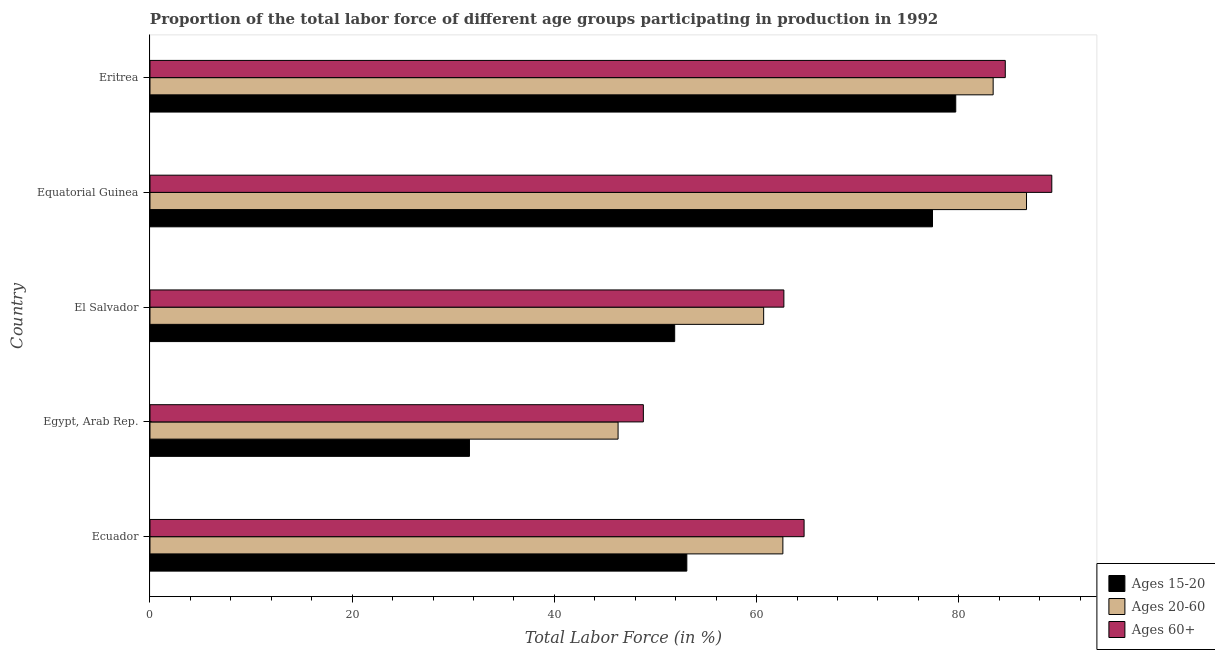How many different coloured bars are there?
Make the answer very short. 3. Are the number of bars per tick equal to the number of legend labels?
Provide a succinct answer. Yes. Are the number of bars on each tick of the Y-axis equal?
Ensure brevity in your answer.  Yes. How many bars are there on the 1st tick from the top?
Your answer should be very brief. 3. How many bars are there on the 1st tick from the bottom?
Provide a short and direct response. 3. What is the label of the 3rd group of bars from the top?
Provide a succinct answer. El Salvador. What is the percentage of labor force within the age group 15-20 in El Salvador?
Offer a very short reply. 51.9. Across all countries, what is the maximum percentage of labor force within the age group 15-20?
Ensure brevity in your answer.  79.7. Across all countries, what is the minimum percentage of labor force within the age group 20-60?
Keep it short and to the point. 46.3. In which country was the percentage of labor force within the age group 15-20 maximum?
Keep it short and to the point. Eritrea. In which country was the percentage of labor force within the age group 15-20 minimum?
Provide a short and direct response. Egypt, Arab Rep. What is the total percentage of labor force within the age group 20-60 in the graph?
Provide a succinct answer. 339.7. What is the difference between the percentage of labor force within the age group 15-20 in Egypt, Arab Rep. and that in Equatorial Guinea?
Provide a succinct answer. -45.8. What is the difference between the percentage of labor force within the age group 15-20 in Eritrea and the percentage of labor force above age 60 in Equatorial Guinea?
Make the answer very short. -9.5. What is the average percentage of labor force within the age group 15-20 per country?
Offer a very short reply. 58.74. What is the difference between the percentage of labor force above age 60 and percentage of labor force within the age group 15-20 in Equatorial Guinea?
Make the answer very short. 11.8. What is the ratio of the percentage of labor force above age 60 in Egypt, Arab Rep. to that in El Salvador?
Ensure brevity in your answer.  0.78. Is the percentage of labor force within the age group 15-20 in Egypt, Arab Rep. less than that in Eritrea?
Ensure brevity in your answer.  Yes. Is the difference between the percentage of labor force within the age group 20-60 in Egypt, Arab Rep. and El Salvador greater than the difference between the percentage of labor force above age 60 in Egypt, Arab Rep. and El Salvador?
Provide a short and direct response. No. What is the difference between the highest and the lowest percentage of labor force within the age group 15-20?
Your response must be concise. 48.1. Is the sum of the percentage of labor force within the age group 20-60 in Ecuador and Equatorial Guinea greater than the maximum percentage of labor force within the age group 15-20 across all countries?
Your response must be concise. Yes. What does the 2nd bar from the top in Eritrea represents?
Give a very brief answer. Ages 20-60. What does the 3rd bar from the bottom in Equatorial Guinea represents?
Give a very brief answer. Ages 60+. What is the difference between two consecutive major ticks on the X-axis?
Your answer should be very brief. 20. Does the graph contain any zero values?
Provide a short and direct response. No. What is the title of the graph?
Your response must be concise. Proportion of the total labor force of different age groups participating in production in 1992. Does "Industry" appear as one of the legend labels in the graph?
Your response must be concise. No. What is the Total Labor Force (in %) in Ages 15-20 in Ecuador?
Your answer should be compact. 53.1. What is the Total Labor Force (in %) of Ages 20-60 in Ecuador?
Offer a terse response. 62.6. What is the Total Labor Force (in %) of Ages 60+ in Ecuador?
Your answer should be compact. 64.7. What is the Total Labor Force (in %) in Ages 15-20 in Egypt, Arab Rep.?
Keep it short and to the point. 31.6. What is the Total Labor Force (in %) in Ages 20-60 in Egypt, Arab Rep.?
Offer a very short reply. 46.3. What is the Total Labor Force (in %) of Ages 60+ in Egypt, Arab Rep.?
Your answer should be very brief. 48.8. What is the Total Labor Force (in %) in Ages 15-20 in El Salvador?
Make the answer very short. 51.9. What is the Total Labor Force (in %) in Ages 20-60 in El Salvador?
Offer a terse response. 60.7. What is the Total Labor Force (in %) of Ages 60+ in El Salvador?
Give a very brief answer. 62.7. What is the Total Labor Force (in %) of Ages 15-20 in Equatorial Guinea?
Ensure brevity in your answer.  77.4. What is the Total Labor Force (in %) of Ages 20-60 in Equatorial Guinea?
Your answer should be compact. 86.7. What is the Total Labor Force (in %) of Ages 60+ in Equatorial Guinea?
Give a very brief answer. 89.2. What is the Total Labor Force (in %) in Ages 15-20 in Eritrea?
Your answer should be very brief. 79.7. What is the Total Labor Force (in %) of Ages 20-60 in Eritrea?
Your answer should be compact. 83.4. What is the Total Labor Force (in %) in Ages 60+ in Eritrea?
Keep it short and to the point. 84.6. Across all countries, what is the maximum Total Labor Force (in %) in Ages 15-20?
Offer a terse response. 79.7. Across all countries, what is the maximum Total Labor Force (in %) of Ages 20-60?
Provide a short and direct response. 86.7. Across all countries, what is the maximum Total Labor Force (in %) in Ages 60+?
Offer a very short reply. 89.2. Across all countries, what is the minimum Total Labor Force (in %) of Ages 15-20?
Offer a terse response. 31.6. Across all countries, what is the minimum Total Labor Force (in %) of Ages 20-60?
Offer a terse response. 46.3. Across all countries, what is the minimum Total Labor Force (in %) in Ages 60+?
Offer a terse response. 48.8. What is the total Total Labor Force (in %) in Ages 15-20 in the graph?
Give a very brief answer. 293.7. What is the total Total Labor Force (in %) of Ages 20-60 in the graph?
Your response must be concise. 339.7. What is the total Total Labor Force (in %) in Ages 60+ in the graph?
Make the answer very short. 350. What is the difference between the Total Labor Force (in %) of Ages 15-20 in Ecuador and that in Egypt, Arab Rep.?
Provide a short and direct response. 21.5. What is the difference between the Total Labor Force (in %) in Ages 20-60 in Ecuador and that in Egypt, Arab Rep.?
Your response must be concise. 16.3. What is the difference between the Total Labor Force (in %) in Ages 60+ in Ecuador and that in Egypt, Arab Rep.?
Keep it short and to the point. 15.9. What is the difference between the Total Labor Force (in %) of Ages 15-20 in Ecuador and that in Equatorial Guinea?
Provide a succinct answer. -24.3. What is the difference between the Total Labor Force (in %) in Ages 20-60 in Ecuador and that in Equatorial Guinea?
Provide a succinct answer. -24.1. What is the difference between the Total Labor Force (in %) of Ages 60+ in Ecuador and that in Equatorial Guinea?
Make the answer very short. -24.5. What is the difference between the Total Labor Force (in %) of Ages 15-20 in Ecuador and that in Eritrea?
Your answer should be compact. -26.6. What is the difference between the Total Labor Force (in %) in Ages 20-60 in Ecuador and that in Eritrea?
Make the answer very short. -20.8. What is the difference between the Total Labor Force (in %) in Ages 60+ in Ecuador and that in Eritrea?
Your response must be concise. -19.9. What is the difference between the Total Labor Force (in %) of Ages 15-20 in Egypt, Arab Rep. and that in El Salvador?
Your answer should be compact. -20.3. What is the difference between the Total Labor Force (in %) in Ages 20-60 in Egypt, Arab Rep. and that in El Salvador?
Your answer should be very brief. -14.4. What is the difference between the Total Labor Force (in %) in Ages 15-20 in Egypt, Arab Rep. and that in Equatorial Guinea?
Make the answer very short. -45.8. What is the difference between the Total Labor Force (in %) in Ages 20-60 in Egypt, Arab Rep. and that in Equatorial Guinea?
Your answer should be compact. -40.4. What is the difference between the Total Labor Force (in %) of Ages 60+ in Egypt, Arab Rep. and that in Equatorial Guinea?
Offer a very short reply. -40.4. What is the difference between the Total Labor Force (in %) of Ages 15-20 in Egypt, Arab Rep. and that in Eritrea?
Your response must be concise. -48.1. What is the difference between the Total Labor Force (in %) in Ages 20-60 in Egypt, Arab Rep. and that in Eritrea?
Your answer should be very brief. -37.1. What is the difference between the Total Labor Force (in %) in Ages 60+ in Egypt, Arab Rep. and that in Eritrea?
Your response must be concise. -35.8. What is the difference between the Total Labor Force (in %) in Ages 15-20 in El Salvador and that in Equatorial Guinea?
Give a very brief answer. -25.5. What is the difference between the Total Labor Force (in %) of Ages 20-60 in El Salvador and that in Equatorial Guinea?
Offer a terse response. -26. What is the difference between the Total Labor Force (in %) of Ages 60+ in El Salvador and that in Equatorial Guinea?
Offer a very short reply. -26.5. What is the difference between the Total Labor Force (in %) of Ages 15-20 in El Salvador and that in Eritrea?
Give a very brief answer. -27.8. What is the difference between the Total Labor Force (in %) of Ages 20-60 in El Salvador and that in Eritrea?
Keep it short and to the point. -22.7. What is the difference between the Total Labor Force (in %) in Ages 60+ in El Salvador and that in Eritrea?
Make the answer very short. -21.9. What is the difference between the Total Labor Force (in %) of Ages 60+ in Equatorial Guinea and that in Eritrea?
Keep it short and to the point. 4.6. What is the difference between the Total Labor Force (in %) of Ages 15-20 in Ecuador and the Total Labor Force (in %) of Ages 20-60 in Egypt, Arab Rep.?
Ensure brevity in your answer.  6.8. What is the difference between the Total Labor Force (in %) of Ages 15-20 in Ecuador and the Total Labor Force (in %) of Ages 60+ in Egypt, Arab Rep.?
Your answer should be very brief. 4.3. What is the difference between the Total Labor Force (in %) of Ages 15-20 in Ecuador and the Total Labor Force (in %) of Ages 60+ in El Salvador?
Your answer should be very brief. -9.6. What is the difference between the Total Labor Force (in %) of Ages 20-60 in Ecuador and the Total Labor Force (in %) of Ages 60+ in El Salvador?
Make the answer very short. -0.1. What is the difference between the Total Labor Force (in %) of Ages 15-20 in Ecuador and the Total Labor Force (in %) of Ages 20-60 in Equatorial Guinea?
Offer a terse response. -33.6. What is the difference between the Total Labor Force (in %) in Ages 15-20 in Ecuador and the Total Labor Force (in %) in Ages 60+ in Equatorial Guinea?
Offer a very short reply. -36.1. What is the difference between the Total Labor Force (in %) of Ages 20-60 in Ecuador and the Total Labor Force (in %) of Ages 60+ in Equatorial Guinea?
Provide a succinct answer. -26.6. What is the difference between the Total Labor Force (in %) in Ages 15-20 in Ecuador and the Total Labor Force (in %) in Ages 20-60 in Eritrea?
Provide a succinct answer. -30.3. What is the difference between the Total Labor Force (in %) of Ages 15-20 in Ecuador and the Total Labor Force (in %) of Ages 60+ in Eritrea?
Your response must be concise. -31.5. What is the difference between the Total Labor Force (in %) of Ages 20-60 in Ecuador and the Total Labor Force (in %) of Ages 60+ in Eritrea?
Give a very brief answer. -22. What is the difference between the Total Labor Force (in %) of Ages 15-20 in Egypt, Arab Rep. and the Total Labor Force (in %) of Ages 20-60 in El Salvador?
Your answer should be very brief. -29.1. What is the difference between the Total Labor Force (in %) of Ages 15-20 in Egypt, Arab Rep. and the Total Labor Force (in %) of Ages 60+ in El Salvador?
Provide a short and direct response. -31.1. What is the difference between the Total Labor Force (in %) in Ages 20-60 in Egypt, Arab Rep. and the Total Labor Force (in %) in Ages 60+ in El Salvador?
Give a very brief answer. -16.4. What is the difference between the Total Labor Force (in %) of Ages 15-20 in Egypt, Arab Rep. and the Total Labor Force (in %) of Ages 20-60 in Equatorial Guinea?
Give a very brief answer. -55.1. What is the difference between the Total Labor Force (in %) of Ages 15-20 in Egypt, Arab Rep. and the Total Labor Force (in %) of Ages 60+ in Equatorial Guinea?
Your response must be concise. -57.6. What is the difference between the Total Labor Force (in %) in Ages 20-60 in Egypt, Arab Rep. and the Total Labor Force (in %) in Ages 60+ in Equatorial Guinea?
Provide a succinct answer. -42.9. What is the difference between the Total Labor Force (in %) of Ages 15-20 in Egypt, Arab Rep. and the Total Labor Force (in %) of Ages 20-60 in Eritrea?
Provide a succinct answer. -51.8. What is the difference between the Total Labor Force (in %) of Ages 15-20 in Egypt, Arab Rep. and the Total Labor Force (in %) of Ages 60+ in Eritrea?
Offer a terse response. -53. What is the difference between the Total Labor Force (in %) of Ages 20-60 in Egypt, Arab Rep. and the Total Labor Force (in %) of Ages 60+ in Eritrea?
Ensure brevity in your answer.  -38.3. What is the difference between the Total Labor Force (in %) of Ages 15-20 in El Salvador and the Total Labor Force (in %) of Ages 20-60 in Equatorial Guinea?
Provide a short and direct response. -34.8. What is the difference between the Total Labor Force (in %) in Ages 15-20 in El Salvador and the Total Labor Force (in %) in Ages 60+ in Equatorial Guinea?
Your response must be concise. -37.3. What is the difference between the Total Labor Force (in %) of Ages 20-60 in El Salvador and the Total Labor Force (in %) of Ages 60+ in Equatorial Guinea?
Provide a short and direct response. -28.5. What is the difference between the Total Labor Force (in %) of Ages 15-20 in El Salvador and the Total Labor Force (in %) of Ages 20-60 in Eritrea?
Provide a succinct answer. -31.5. What is the difference between the Total Labor Force (in %) of Ages 15-20 in El Salvador and the Total Labor Force (in %) of Ages 60+ in Eritrea?
Offer a terse response. -32.7. What is the difference between the Total Labor Force (in %) of Ages 20-60 in El Salvador and the Total Labor Force (in %) of Ages 60+ in Eritrea?
Provide a succinct answer. -23.9. What is the difference between the Total Labor Force (in %) in Ages 15-20 in Equatorial Guinea and the Total Labor Force (in %) in Ages 20-60 in Eritrea?
Provide a succinct answer. -6. What is the difference between the Total Labor Force (in %) of Ages 15-20 in Equatorial Guinea and the Total Labor Force (in %) of Ages 60+ in Eritrea?
Your answer should be very brief. -7.2. What is the average Total Labor Force (in %) of Ages 15-20 per country?
Provide a short and direct response. 58.74. What is the average Total Labor Force (in %) in Ages 20-60 per country?
Your response must be concise. 67.94. What is the average Total Labor Force (in %) in Ages 60+ per country?
Your answer should be compact. 70. What is the difference between the Total Labor Force (in %) of Ages 15-20 and Total Labor Force (in %) of Ages 20-60 in Egypt, Arab Rep.?
Make the answer very short. -14.7. What is the difference between the Total Labor Force (in %) of Ages 15-20 and Total Labor Force (in %) of Ages 60+ in Egypt, Arab Rep.?
Offer a terse response. -17.2. What is the difference between the Total Labor Force (in %) of Ages 20-60 and Total Labor Force (in %) of Ages 60+ in Egypt, Arab Rep.?
Your response must be concise. -2.5. What is the difference between the Total Labor Force (in %) of Ages 15-20 and Total Labor Force (in %) of Ages 20-60 in El Salvador?
Your response must be concise. -8.8. What is the difference between the Total Labor Force (in %) of Ages 20-60 and Total Labor Force (in %) of Ages 60+ in El Salvador?
Provide a short and direct response. -2. What is the difference between the Total Labor Force (in %) of Ages 15-20 and Total Labor Force (in %) of Ages 60+ in Equatorial Guinea?
Provide a short and direct response. -11.8. What is the difference between the Total Labor Force (in %) in Ages 20-60 and Total Labor Force (in %) in Ages 60+ in Equatorial Guinea?
Provide a short and direct response. -2.5. What is the difference between the Total Labor Force (in %) of Ages 15-20 and Total Labor Force (in %) of Ages 20-60 in Eritrea?
Your answer should be compact. -3.7. What is the difference between the Total Labor Force (in %) of Ages 15-20 and Total Labor Force (in %) of Ages 60+ in Eritrea?
Offer a very short reply. -4.9. What is the difference between the Total Labor Force (in %) in Ages 20-60 and Total Labor Force (in %) in Ages 60+ in Eritrea?
Your answer should be very brief. -1.2. What is the ratio of the Total Labor Force (in %) of Ages 15-20 in Ecuador to that in Egypt, Arab Rep.?
Offer a very short reply. 1.68. What is the ratio of the Total Labor Force (in %) in Ages 20-60 in Ecuador to that in Egypt, Arab Rep.?
Your answer should be very brief. 1.35. What is the ratio of the Total Labor Force (in %) in Ages 60+ in Ecuador to that in Egypt, Arab Rep.?
Offer a very short reply. 1.33. What is the ratio of the Total Labor Force (in %) in Ages 15-20 in Ecuador to that in El Salvador?
Make the answer very short. 1.02. What is the ratio of the Total Labor Force (in %) in Ages 20-60 in Ecuador to that in El Salvador?
Your answer should be very brief. 1.03. What is the ratio of the Total Labor Force (in %) of Ages 60+ in Ecuador to that in El Salvador?
Provide a short and direct response. 1.03. What is the ratio of the Total Labor Force (in %) of Ages 15-20 in Ecuador to that in Equatorial Guinea?
Keep it short and to the point. 0.69. What is the ratio of the Total Labor Force (in %) in Ages 20-60 in Ecuador to that in Equatorial Guinea?
Ensure brevity in your answer.  0.72. What is the ratio of the Total Labor Force (in %) of Ages 60+ in Ecuador to that in Equatorial Guinea?
Provide a succinct answer. 0.73. What is the ratio of the Total Labor Force (in %) of Ages 15-20 in Ecuador to that in Eritrea?
Your response must be concise. 0.67. What is the ratio of the Total Labor Force (in %) in Ages 20-60 in Ecuador to that in Eritrea?
Your answer should be very brief. 0.75. What is the ratio of the Total Labor Force (in %) in Ages 60+ in Ecuador to that in Eritrea?
Ensure brevity in your answer.  0.76. What is the ratio of the Total Labor Force (in %) in Ages 15-20 in Egypt, Arab Rep. to that in El Salvador?
Give a very brief answer. 0.61. What is the ratio of the Total Labor Force (in %) of Ages 20-60 in Egypt, Arab Rep. to that in El Salvador?
Provide a short and direct response. 0.76. What is the ratio of the Total Labor Force (in %) of Ages 60+ in Egypt, Arab Rep. to that in El Salvador?
Offer a terse response. 0.78. What is the ratio of the Total Labor Force (in %) in Ages 15-20 in Egypt, Arab Rep. to that in Equatorial Guinea?
Your answer should be very brief. 0.41. What is the ratio of the Total Labor Force (in %) in Ages 20-60 in Egypt, Arab Rep. to that in Equatorial Guinea?
Offer a very short reply. 0.53. What is the ratio of the Total Labor Force (in %) of Ages 60+ in Egypt, Arab Rep. to that in Equatorial Guinea?
Your response must be concise. 0.55. What is the ratio of the Total Labor Force (in %) in Ages 15-20 in Egypt, Arab Rep. to that in Eritrea?
Your answer should be very brief. 0.4. What is the ratio of the Total Labor Force (in %) of Ages 20-60 in Egypt, Arab Rep. to that in Eritrea?
Give a very brief answer. 0.56. What is the ratio of the Total Labor Force (in %) of Ages 60+ in Egypt, Arab Rep. to that in Eritrea?
Provide a short and direct response. 0.58. What is the ratio of the Total Labor Force (in %) of Ages 15-20 in El Salvador to that in Equatorial Guinea?
Provide a succinct answer. 0.67. What is the ratio of the Total Labor Force (in %) in Ages 20-60 in El Salvador to that in Equatorial Guinea?
Give a very brief answer. 0.7. What is the ratio of the Total Labor Force (in %) of Ages 60+ in El Salvador to that in Equatorial Guinea?
Offer a terse response. 0.7. What is the ratio of the Total Labor Force (in %) of Ages 15-20 in El Salvador to that in Eritrea?
Offer a very short reply. 0.65. What is the ratio of the Total Labor Force (in %) in Ages 20-60 in El Salvador to that in Eritrea?
Offer a very short reply. 0.73. What is the ratio of the Total Labor Force (in %) of Ages 60+ in El Salvador to that in Eritrea?
Provide a short and direct response. 0.74. What is the ratio of the Total Labor Force (in %) in Ages 15-20 in Equatorial Guinea to that in Eritrea?
Ensure brevity in your answer.  0.97. What is the ratio of the Total Labor Force (in %) in Ages 20-60 in Equatorial Guinea to that in Eritrea?
Offer a very short reply. 1.04. What is the ratio of the Total Labor Force (in %) in Ages 60+ in Equatorial Guinea to that in Eritrea?
Make the answer very short. 1.05. What is the difference between the highest and the second highest Total Labor Force (in %) in Ages 15-20?
Your answer should be very brief. 2.3. What is the difference between the highest and the lowest Total Labor Force (in %) in Ages 15-20?
Give a very brief answer. 48.1. What is the difference between the highest and the lowest Total Labor Force (in %) of Ages 20-60?
Offer a terse response. 40.4. What is the difference between the highest and the lowest Total Labor Force (in %) of Ages 60+?
Your answer should be very brief. 40.4. 